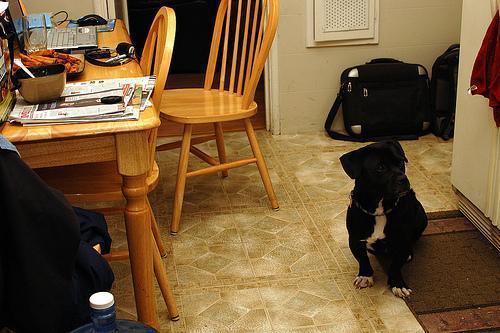How many chairs are in the picture?
Give a very brief answer. 2. 